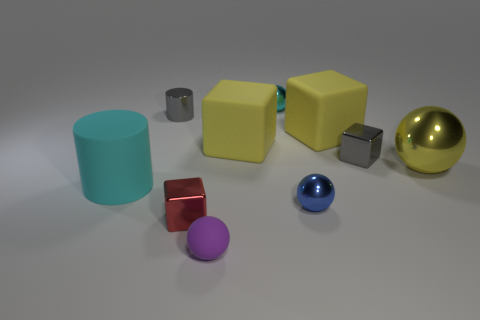How many yellow cubes must be subtracted to get 1 yellow cubes? 1 Subtract all cyan balls. How many balls are left? 3 Subtract 1 blocks. How many blocks are left? 3 Subtract all small gray cubes. How many cubes are left? 3 Subtract all gray spheres. Subtract all yellow blocks. How many spheres are left? 4 Subtract all cylinders. How many objects are left? 8 Subtract 0 green cylinders. How many objects are left? 10 Subtract all metallic objects. Subtract all big spheres. How many objects are left? 3 Add 9 tiny red metal things. How many tiny red metal things are left? 10 Add 4 tiny purple balls. How many tiny purple balls exist? 5 